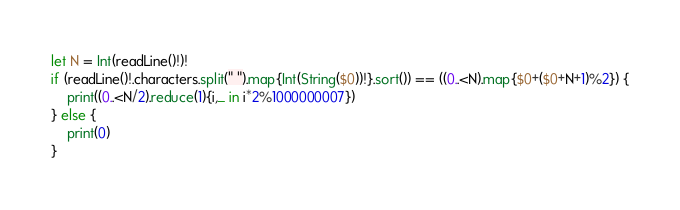Convert code to text. <code><loc_0><loc_0><loc_500><loc_500><_Swift_>let N = Int(readLine()!)!
if (readLine()!.characters.split(" ").map{Int(String($0))!}.sort()) == ((0..<N).map{$0+($0+N+1)%2}) {
    print((0..<N/2).reduce(1){i,_ in i*2%1000000007})
} else {
    print(0)
}</code> 